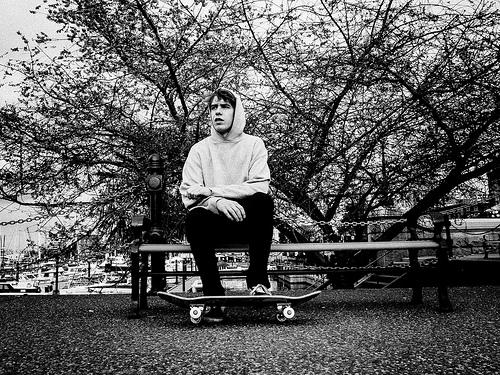Question: why is it so bright?
Choices:
A. Sun light.
B. Hit wattage bulb.
C. Cause it is so dark outside.
D. Surgeons light.
Answer with the letter. Answer: A Question: what is the man sitting on?
Choices:
A. The bench.
B. A couch.
C. A chair.
D. A crate.
Answer with the letter. Answer: A Question: who is on the bench?
Choices:
A. The women.
B. The kids.
C. The man.
D. The grandparents.
Answer with the letter. Answer: C 